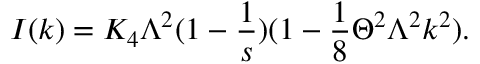<formula> <loc_0><loc_0><loc_500><loc_500>I ( k ) = K _ { 4 } \Lambda ^ { 2 } ( 1 - \frac { 1 } { s } ) ( 1 - \frac { 1 } { 8 } \Theta ^ { 2 } \Lambda ^ { 2 } k ^ { 2 } ) .</formula> 